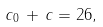<formula> <loc_0><loc_0><loc_500><loc_500>c _ { 0 } \, + \, c = 2 6 ,</formula> 